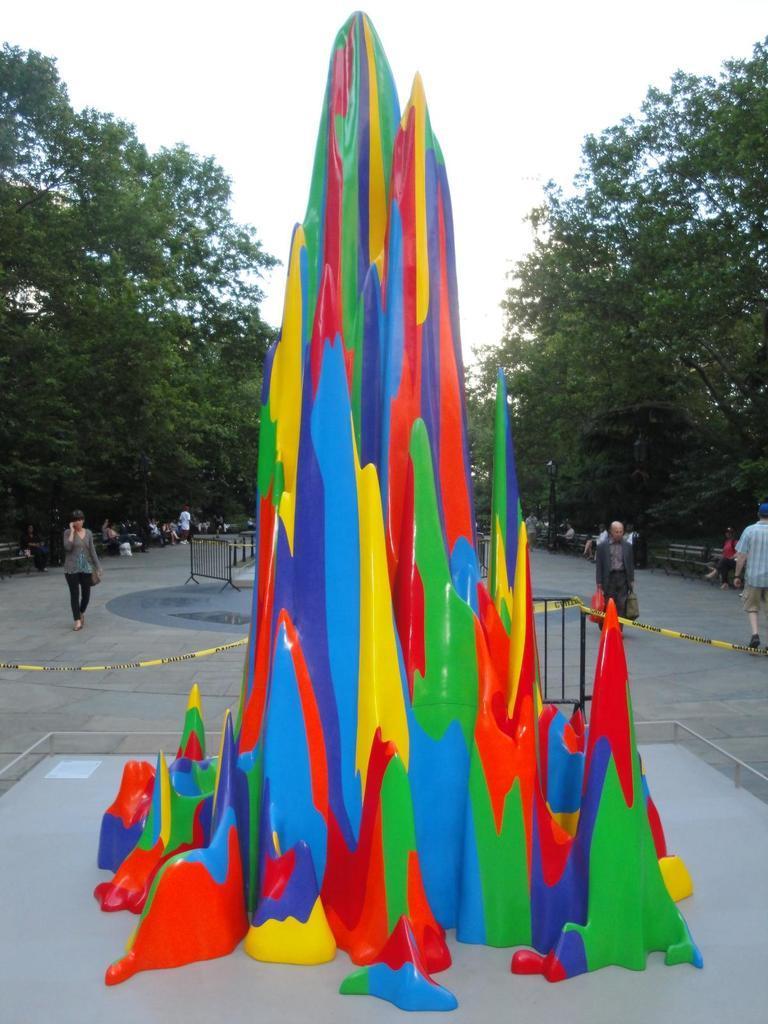In one or two sentences, can you explain what this image depicts? In this image there is the sky towards the top of the image, there are trees, there are group of persons, they are sitting, there are two men walking, there is a man holding an object, there is a woman wearing a bag, there is a fence, there is a multi colored object that looks like a mountain. 